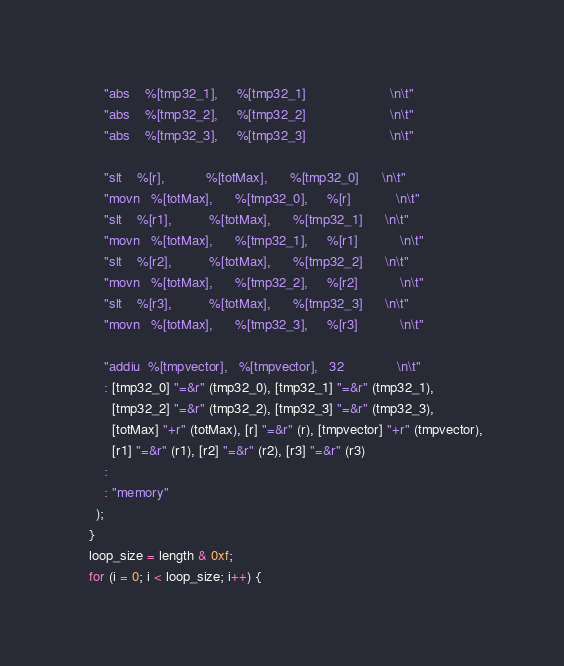<code> <loc_0><loc_0><loc_500><loc_500><_C_>      "abs    %[tmp32_1],     %[tmp32_1]                      \n\t"
      "abs    %[tmp32_2],     %[tmp32_2]                      \n\t"
      "abs    %[tmp32_3],     %[tmp32_3]                      \n\t"

      "slt    %[r],           %[totMax],      %[tmp32_0]      \n\t"
      "movn   %[totMax],      %[tmp32_0],     %[r]            \n\t"
      "slt    %[r1],          %[totMax],      %[tmp32_1]      \n\t"
      "movn   %[totMax],      %[tmp32_1],     %[r1]           \n\t"
      "slt    %[r2],          %[totMax],      %[tmp32_2]      \n\t"
      "movn   %[totMax],      %[tmp32_2],     %[r2]           \n\t"
      "slt    %[r3],          %[totMax],      %[tmp32_3]      \n\t"
      "movn   %[totMax],      %[tmp32_3],     %[r3]           \n\t"

      "addiu  %[tmpvector],   %[tmpvector],   32              \n\t"
      : [tmp32_0] "=&r" (tmp32_0), [tmp32_1] "=&r" (tmp32_1),
        [tmp32_2] "=&r" (tmp32_2), [tmp32_3] "=&r" (tmp32_3),
        [totMax] "+r" (totMax), [r] "=&r" (r), [tmpvector] "+r" (tmpvector),
        [r1] "=&r" (r1), [r2] "=&r" (r2), [r3] "=&r" (r3)
      :
      : "memory"
    );
  }
  loop_size = length & 0xf;
  for (i = 0; i < loop_size; i++) {</code> 